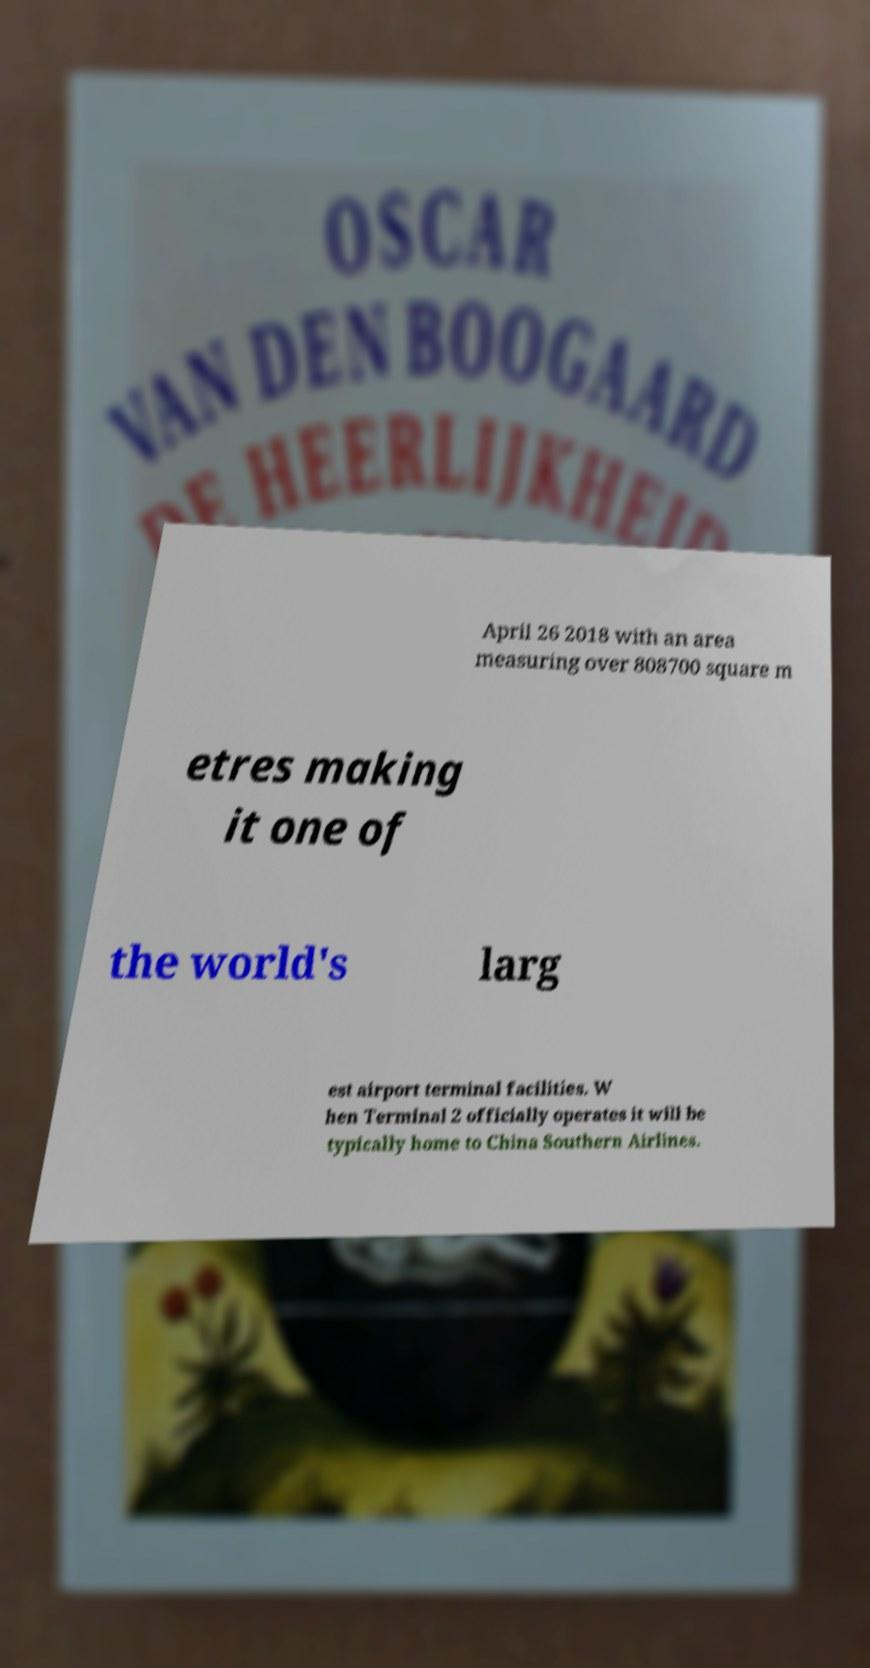Please read and relay the text visible in this image. What does it say? April 26 2018 with an area measuring over 808700 square m etres making it one of the world's larg est airport terminal facilities. W hen Terminal 2 officially operates it will be typically home to China Southern Airlines. 